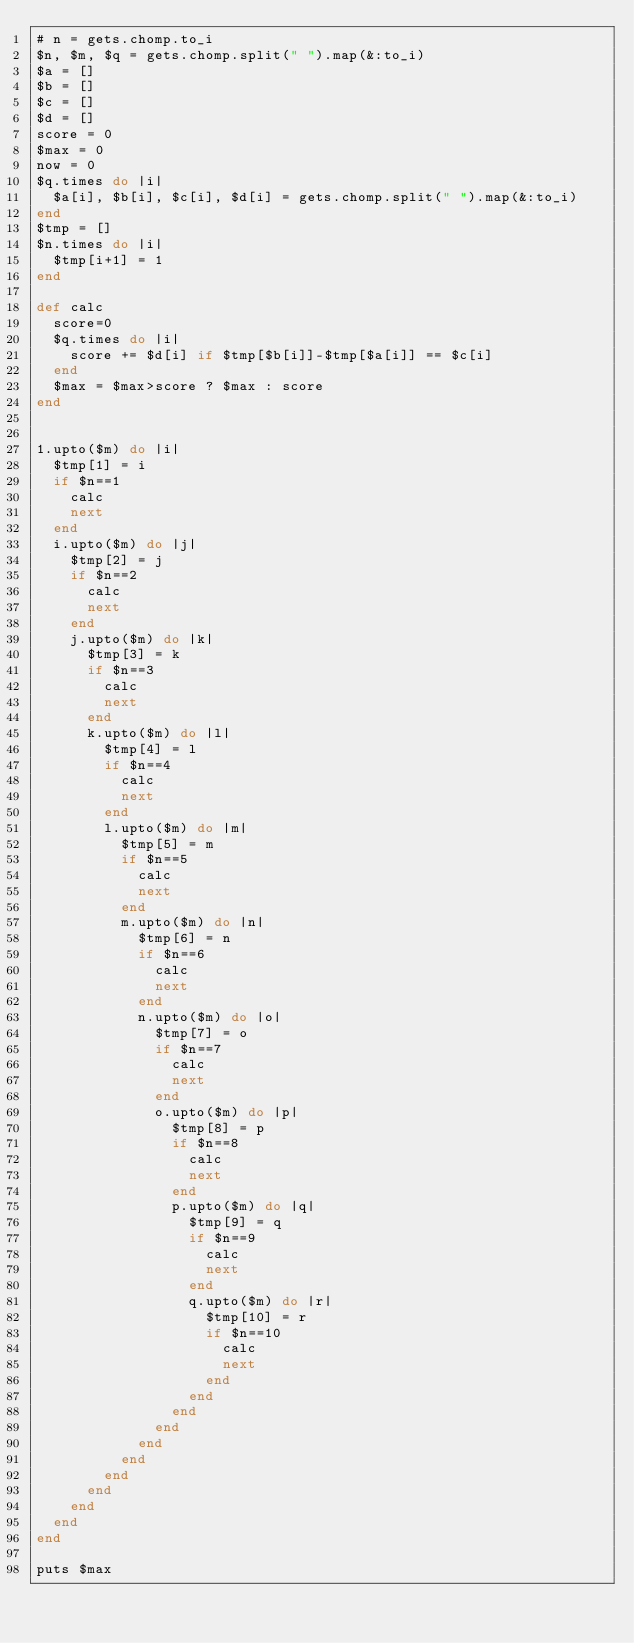Convert code to text. <code><loc_0><loc_0><loc_500><loc_500><_Ruby_># n = gets.chomp.to_i
$n, $m, $q = gets.chomp.split(" ").map(&:to_i)
$a = []
$b = []
$c = []
$d = []
score = 0
$max = 0
now = 0
$q.times do |i|
  $a[i], $b[i], $c[i], $d[i] = gets.chomp.split(" ").map(&:to_i)
end
$tmp = []
$n.times do |i|
  $tmp[i+1] = 1
end

def calc
  score=0
  $q.times do |i|
    score += $d[i] if $tmp[$b[i]]-$tmp[$a[i]] == $c[i]
  end
  $max = $max>score ? $max : score
end


1.upto($m) do |i|
  $tmp[1] = i
  if $n==1
    calc
    next
  end
  i.upto($m) do |j|
    $tmp[2] = j
    if $n==2
      calc
      next
    end
    j.upto($m) do |k|
      $tmp[3] = k
      if $n==3
        calc
        next
      end
      k.upto($m) do |l|
        $tmp[4] = l
        if $n==4
          calc
          next
        end
        l.upto($m) do |m|
          $tmp[5] = m
          if $n==5
            calc
            next
          end
          m.upto($m) do |n|
            $tmp[6] = n
            if $n==6
              calc
              next
            end
            n.upto($m) do |o|
              $tmp[7] = o
              if $n==7
                calc
                next
              end
              o.upto($m) do |p|
                $tmp[8] = p
                if $n==8
                  calc
                  next
                end
                p.upto($m) do |q|
                  $tmp[9] = q
                  if $n==9
                    calc
                    next
                  end
                  q.upto($m) do |r|
                    $tmp[10] = r
                    if $n==10
                      calc
                      next
                    end
                  end
                end
              end
            end
          end
        end
      end
    end
  end
end

puts $max</code> 